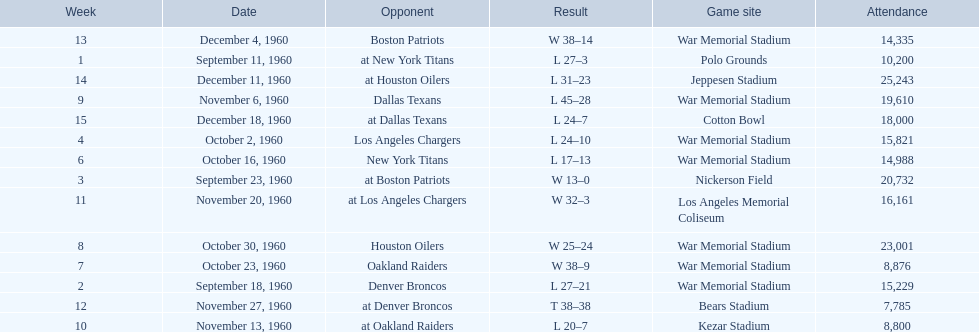How many games had an attendance of 10,000 at most? 11. 